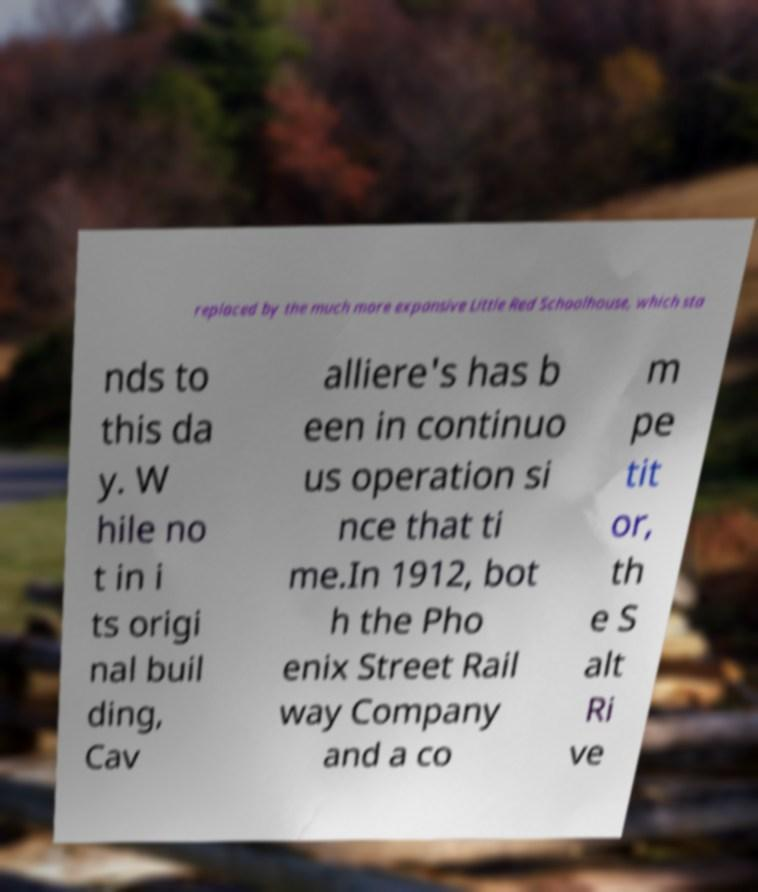What messages or text are displayed in this image? I need them in a readable, typed format. replaced by the much more expansive Little Red Schoolhouse, which sta nds to this da y. W hile no t in i ts origi nal buil ding, Cav alliere's has b een in continuo us operation si nce that ti me.In 1912, bot h the Pho enix Street Rail way Company and a co m pe tit or, th e S alt Ri ve 